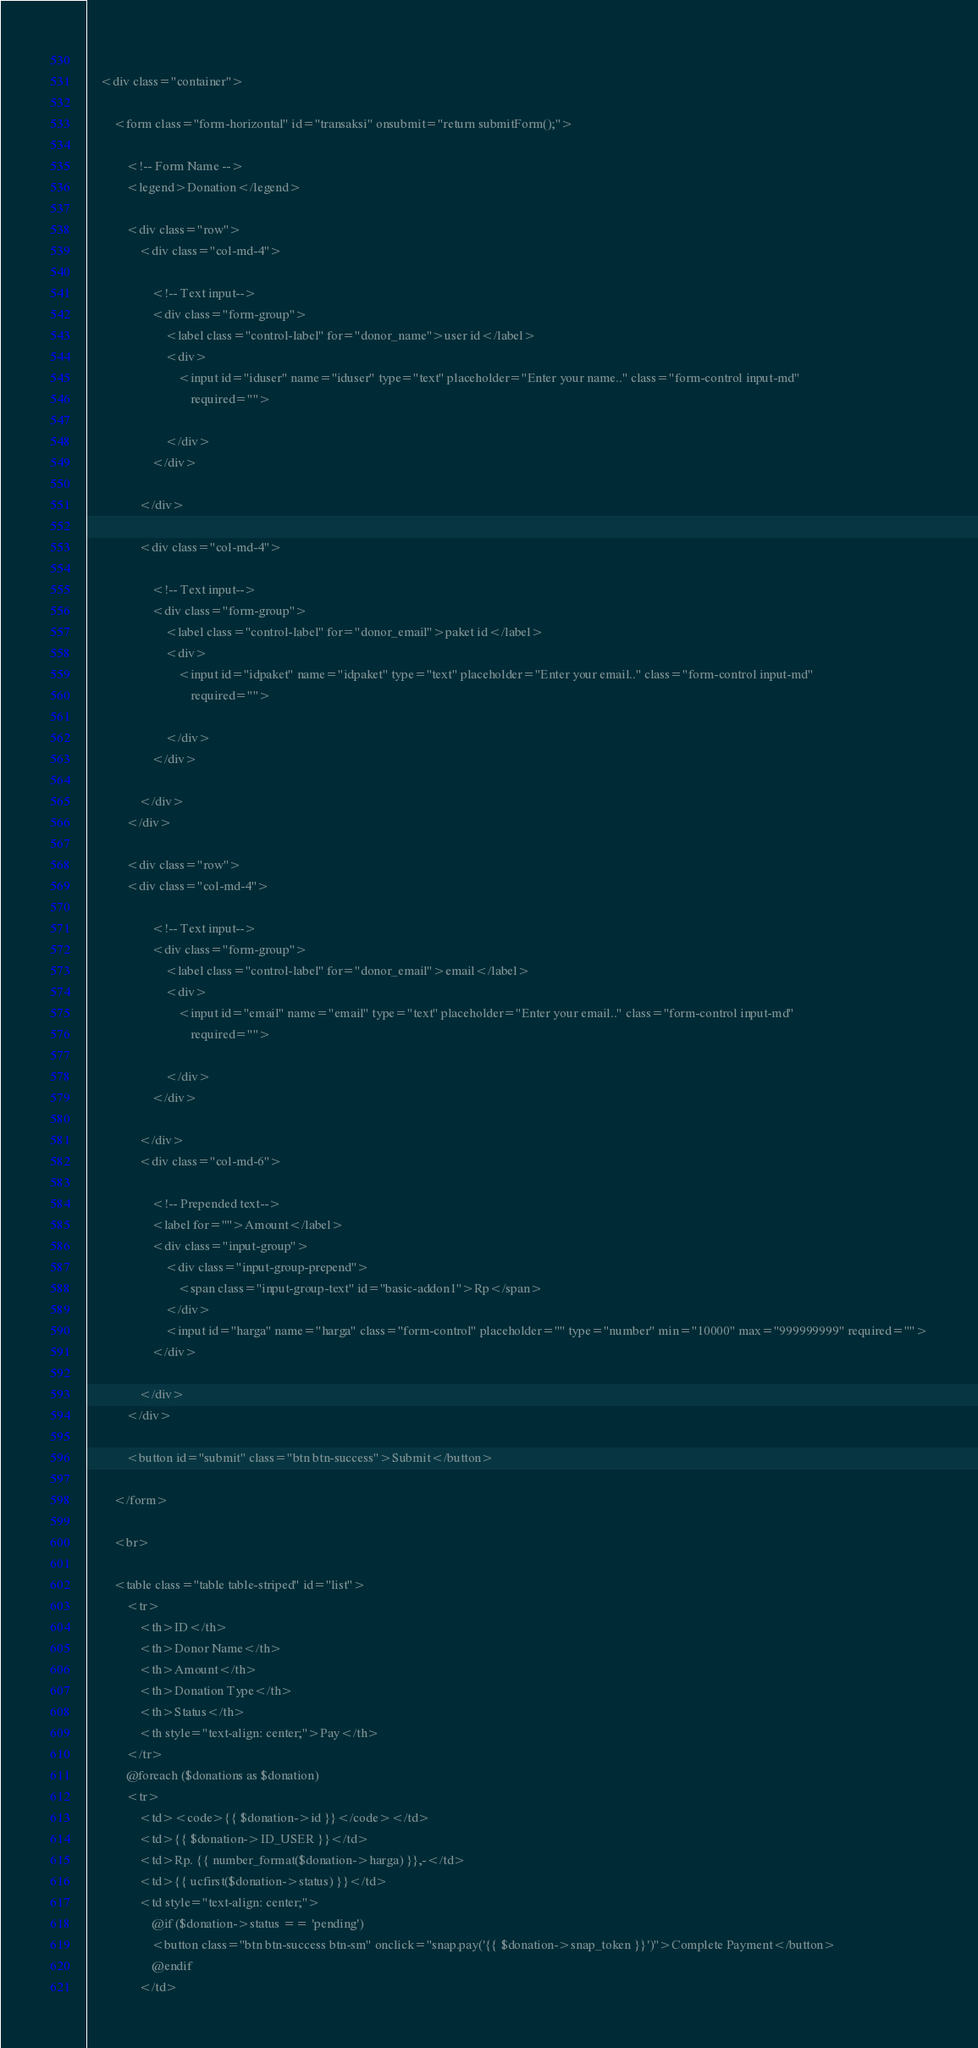<code> <loc_0><loc_0><loc_500><loc_500><_PHP_> 
    <div class="container">
 
        <form class="form-horizontal" id="transaksi" onsubmit="return submitForm();">
 
            <!-- Form Name -->
            <legend>Donation</legend>
 
            <div class="row">
                <div class="col-md-4">
 
                    <!-- Text input-->
                    <div class="form-group">
                        <label class="control-label" for="donor_name">user id</label>
                        <div>
                            <input id="iduser" name="iduser" type="text" placeholder="Enter your name.." class="form-control input-md"
                                required="">
 
                        </div>
                    </div>
 
                </div>
 
                <div class="col-md-4">
 
                    <!-- Text input-->
                    <div class="form-group">
                        <label class="control-label" for="donor_email">paket id</label>
                        <div>
                            <input id="idpaket" name="idpaket" type="text" placeholder="Enter your email.." class="form-control input-md"
                                required="">
    
                        </div>
                    </div>
    
                </div>
            </div>
 
            <div class="row">
            <div class="col-md-4">
 
                    <!-- Text input-->
                    <div class="form-group">
                        <label class="control-label" for="donor_email">email</label>
                        <div>
                            <input id="email" name="email" type="text" placeholder="Enter your email.." class="form-control input-md"
                                required="">
    
                        </div>
                    </div>
    
                </div>
                <div class="col-md-6">
 
                    <!-- Prepended text-->
                    <label for="">Amount</label>
                    <div class="input-group">
                        <div class="input-group-prepend">
                            <span class="input-group-text" id="basic-addon1">Rp</span>
                        </div>
                        <input id="harga" name="harga" class="form-control" placeholder="" type="number" min="10000" max="999999999" required="">
                    </div>
 
                </div>
            </div>
 
            <button id="submit" class="btn btn-success">Submit</button>
 
        </form>
 
        <br>
 
        <table class="table table-striped" id="list">
            <tr>
                <th>ID</th>
                <th>Donor Name</th>
                <th>Amount</th>
                <th>Donation Type</th>
                <th>Status</th>
                <th style="text-align: center;">Pay</th>
            </tr>
            @foreach ($donations as $donation)
            <tr>
                <td><code>{{ $donation->id }}</code></td>
                <td>{{ $donation->ID_USER }}</td>
                <td>Rp. {{ number_format($donation->harga) }},-</td>
                <td>{{ ucfirst($donation->status) }}</td>
                <td style="text-align: center;">
                    @if ($donation->status == 'pending')
                    <button class="btn btn-success btn-sm" onclick="snap.pay('{{ $donation->snap_token }}')">Complete Payment</button>
                    @endif
                </td></code> 